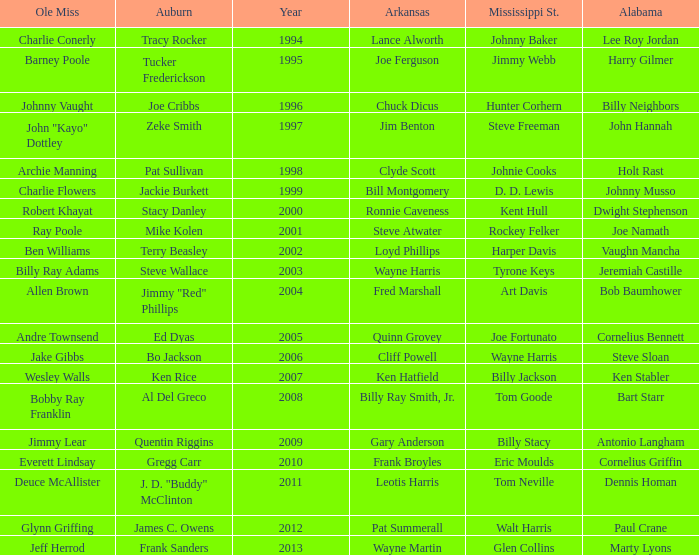Who was the player associated with Ole Miss in years after 2008 with a Mississippi St. name of Eric Moulds? Everett Lindsay. 